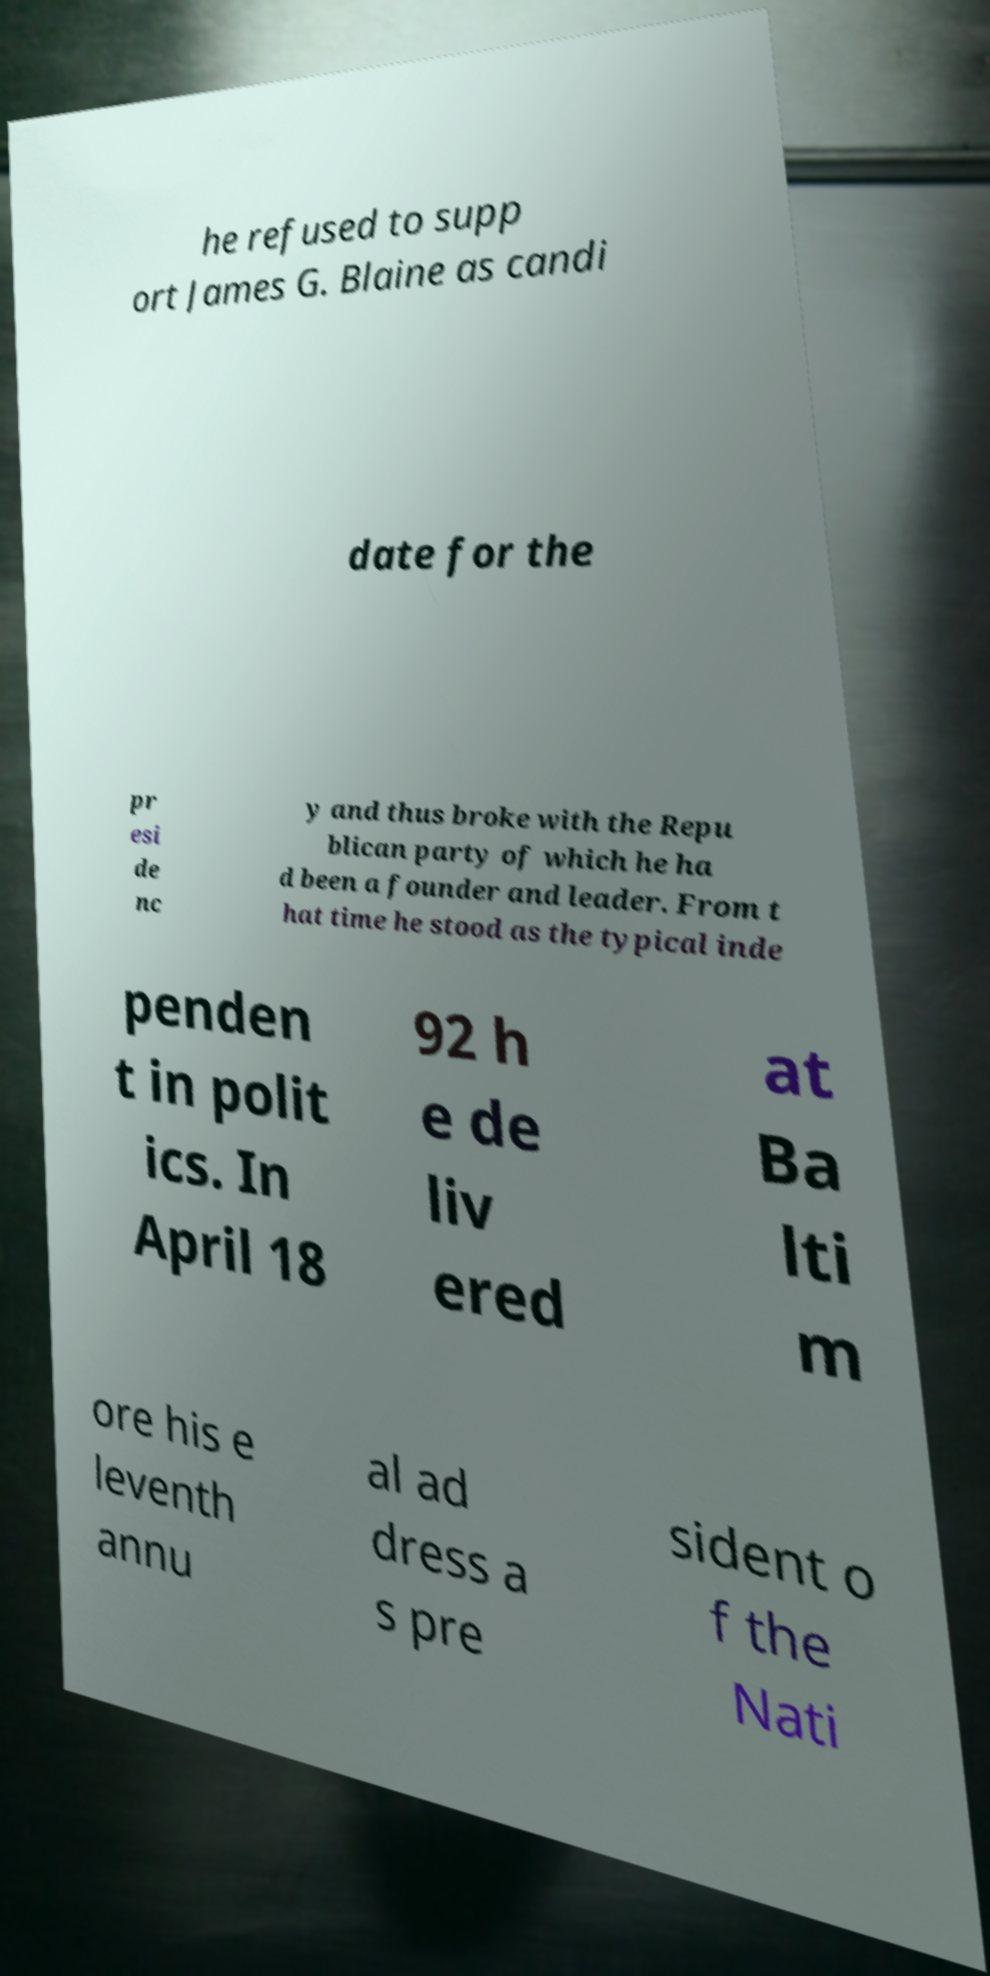For documentation purposes, I need the text within this image transcribed. Could you provide that? he refused to supp ort James G. Blaine as candi date for the pr esi de nc y and thus broke with the Repu blican party of which he ha d been a founder and leader. From t hat time he stood as the typical inde penden t in polit ics. In April 18 92 h e de liv ered at Ba lti m ore his e leventh annu al ad dress a s pre sident o f the Nati 